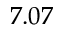<formula> <loc_0><loc_0><loc_500><loc_500>7 . 0 7</formula> 